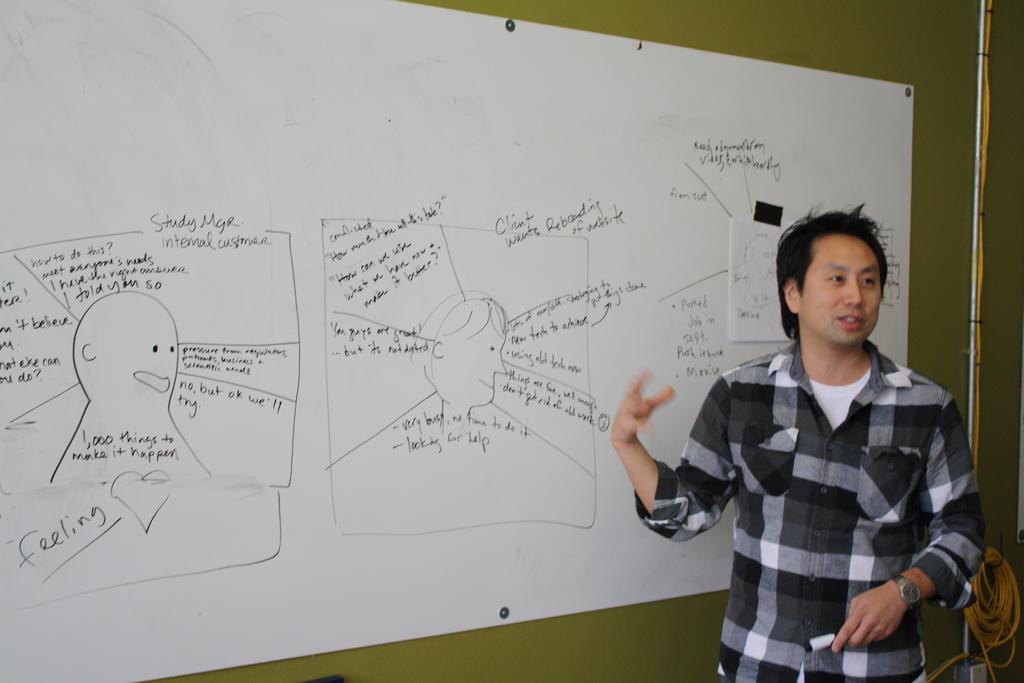What does the largest word on the bottom left say?
Provide a short and direct response. Feeling. 